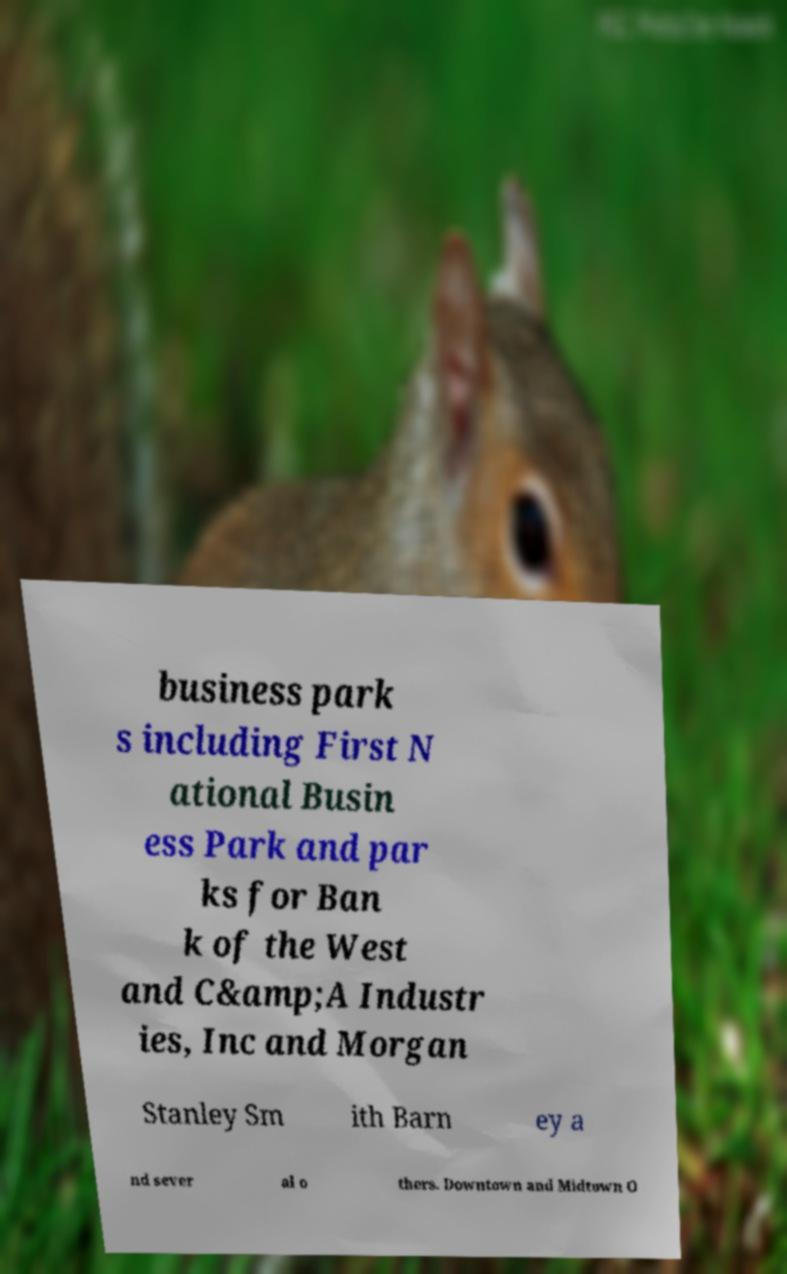There's text embedded in this image that I need extracted. Can you transcribe it verbatim? business park s including First N ational Busin ess Park and par ks for Ban k of the West and C&amp;A Industr ies, Inc and Morgan Stanley Sm ith Barn ey a nd sever al o thers. Downtown and Midtown O 